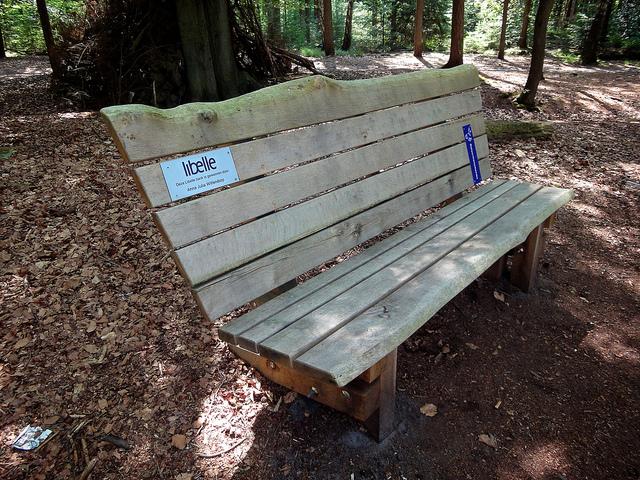How many signs are on the bench?
Be succinct. 2. How many legs are on the bench?
Quick response, please. 2. What color is the sign on the right of the bench?
Keep it brief. Blue. Who was this bench dedicated to?
Concise answer only. Libelle. Is the grass green?
Give a very brief answer. No. Can we see what is to the right of the bench?
Short answer required. Yes. 